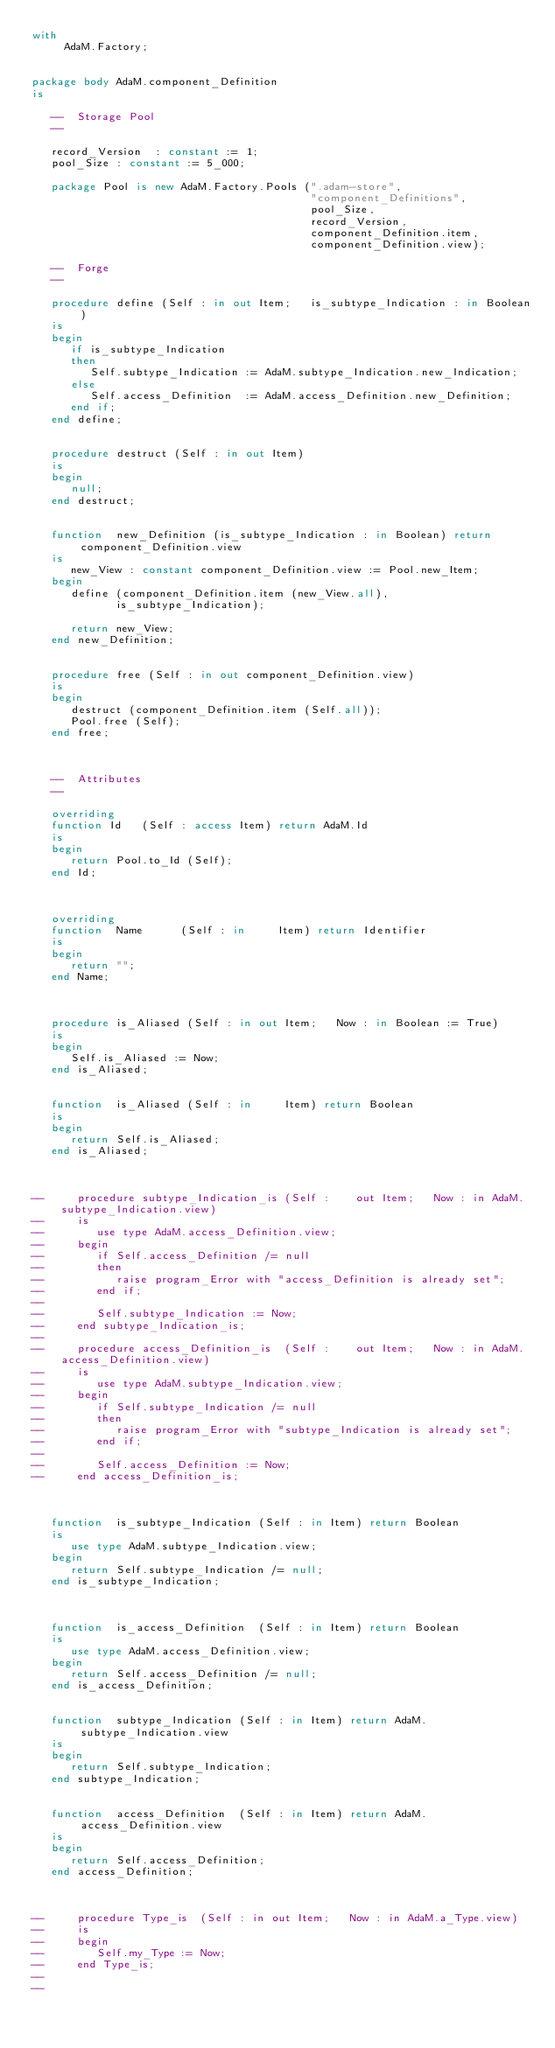Convert code to text. <code><loc_0><loc_0><loc_500><loc_500><_Ada_>with
     AdaM.Factory;


package body AdaM.component_Definition
is

   --  Storage Pool
   --

   record_Version  : constant := 1;
   pool_Size : constant := 5_000;

   package Pool is new AdaM.Factory.Pools (".adam-store",
                                           "component_Definitions",
                                           pool_Size,
                                           record_Version,
                                           component_Definition.item,
                                           component_Definition.view);

   --  Forge
   --

   procedure define (Self : in out Item;   is_subtype_Indication : in Boolean)
   is
   begin
      if is_subtype_Indication
      then
         Self.subtype_Indication := AdaM.subtype_Indication.new_Indication;
      else
         Self.access_Definition  := AdaM.access_Definition.new_Definition;
      end if;
   end define;


   procedure destruct (Self : in out Item)
   is
   begin
      null;
   end destruct;


   function  new_Definition (is_subtype_Indication : in Boolean) return component_Definition.view
   is
      new_View : constant component_Definition.view := Pool.new_Item;
   begin
      define (component_Definition.item (new_View.all),
             is_subtype_Indication);

      return new_View;
   end new_Definition;


   procedure free (Self : in out component_Definition.view)
   is
   begin
      destruct (component_Definition.item (Self.all));
      Pool.free (Self);
   end free;



   --  Attributes
   --

   overriding
   function Id   (Self : access Item) return AdaM.Id
   is
   begin
      return Pool.to_Id (Self);
   end Id;



   overriding
   function  Name      (Self : in     Item) return Identifier
   is
   begin
      return "";
   end Name;



   procedure is_Aliased (Self : in out Item;   Now : in Boolean := True)
   is
   begin
      Self.is_Aliased := Now;
   end is_Aliased;


   function  is_Aliased (Self : in     Item) return Boolean
   is
   begin
      return Self.is_Aliased;
   end is_Aliased;



--     procedure subtype_Indication_is (Self :    out Item;   Now : in AdaM.subtype_Indication.view)
--     is
--        use type AdaM.access_Definition.view;
--     begin
--        if Self.access_Definition /= null
--        then
--           raise program_Error with "access_Definition is already set";
--        end if;
--
--        Self.subtype_Indication := Now;
--     end subtype_Indication_is;
--
--     procedure access_Definition_is  (Self :    out Item;   Now : in AdaM.access_Definition.view)
--     is
--        use type AdaM.subtype_Indication.view;
--     begin
--        if Self.subtype_Indication /= null
--        then
--           raise program_Error with "subtype_Indication is already set";
--        end if;
--
--        Self.access_Definition := Now;
--     end access_Definition_is;



   function  is_subtype_Indication (Self : in Item) return Boolean
   is
      use type AdaM.subtype_Indication.view;
   begin
      return Self.subtype_Indication /= null;
   end is_subtype_Indication;



   function  is_access_Definition  (Self : in Item) return Boolean
   is
      use type AdaM.access_Definition.view;
   begin
      return Self.access_Definition /= null;
   end is_access_Definition;


   function  subtype_Indication (Self : in Item) return AdaM.subtype_Indication.view
   is
   begin
      return Self.subtype_Indication;
   end subtype_Indication;


   function  access_Definition  (Self : in Item) return AdaM.access_Definition.view
   is
   begin
      return Self.access_Definition;
   end access_Definition;



--     procedure Type_is  (Self : in out Item;   Now : in AdaM.a_Type.view)
--     is
--     begin
--        Self.my_Type := Now;
--     end Type_is;
--
--</code> 